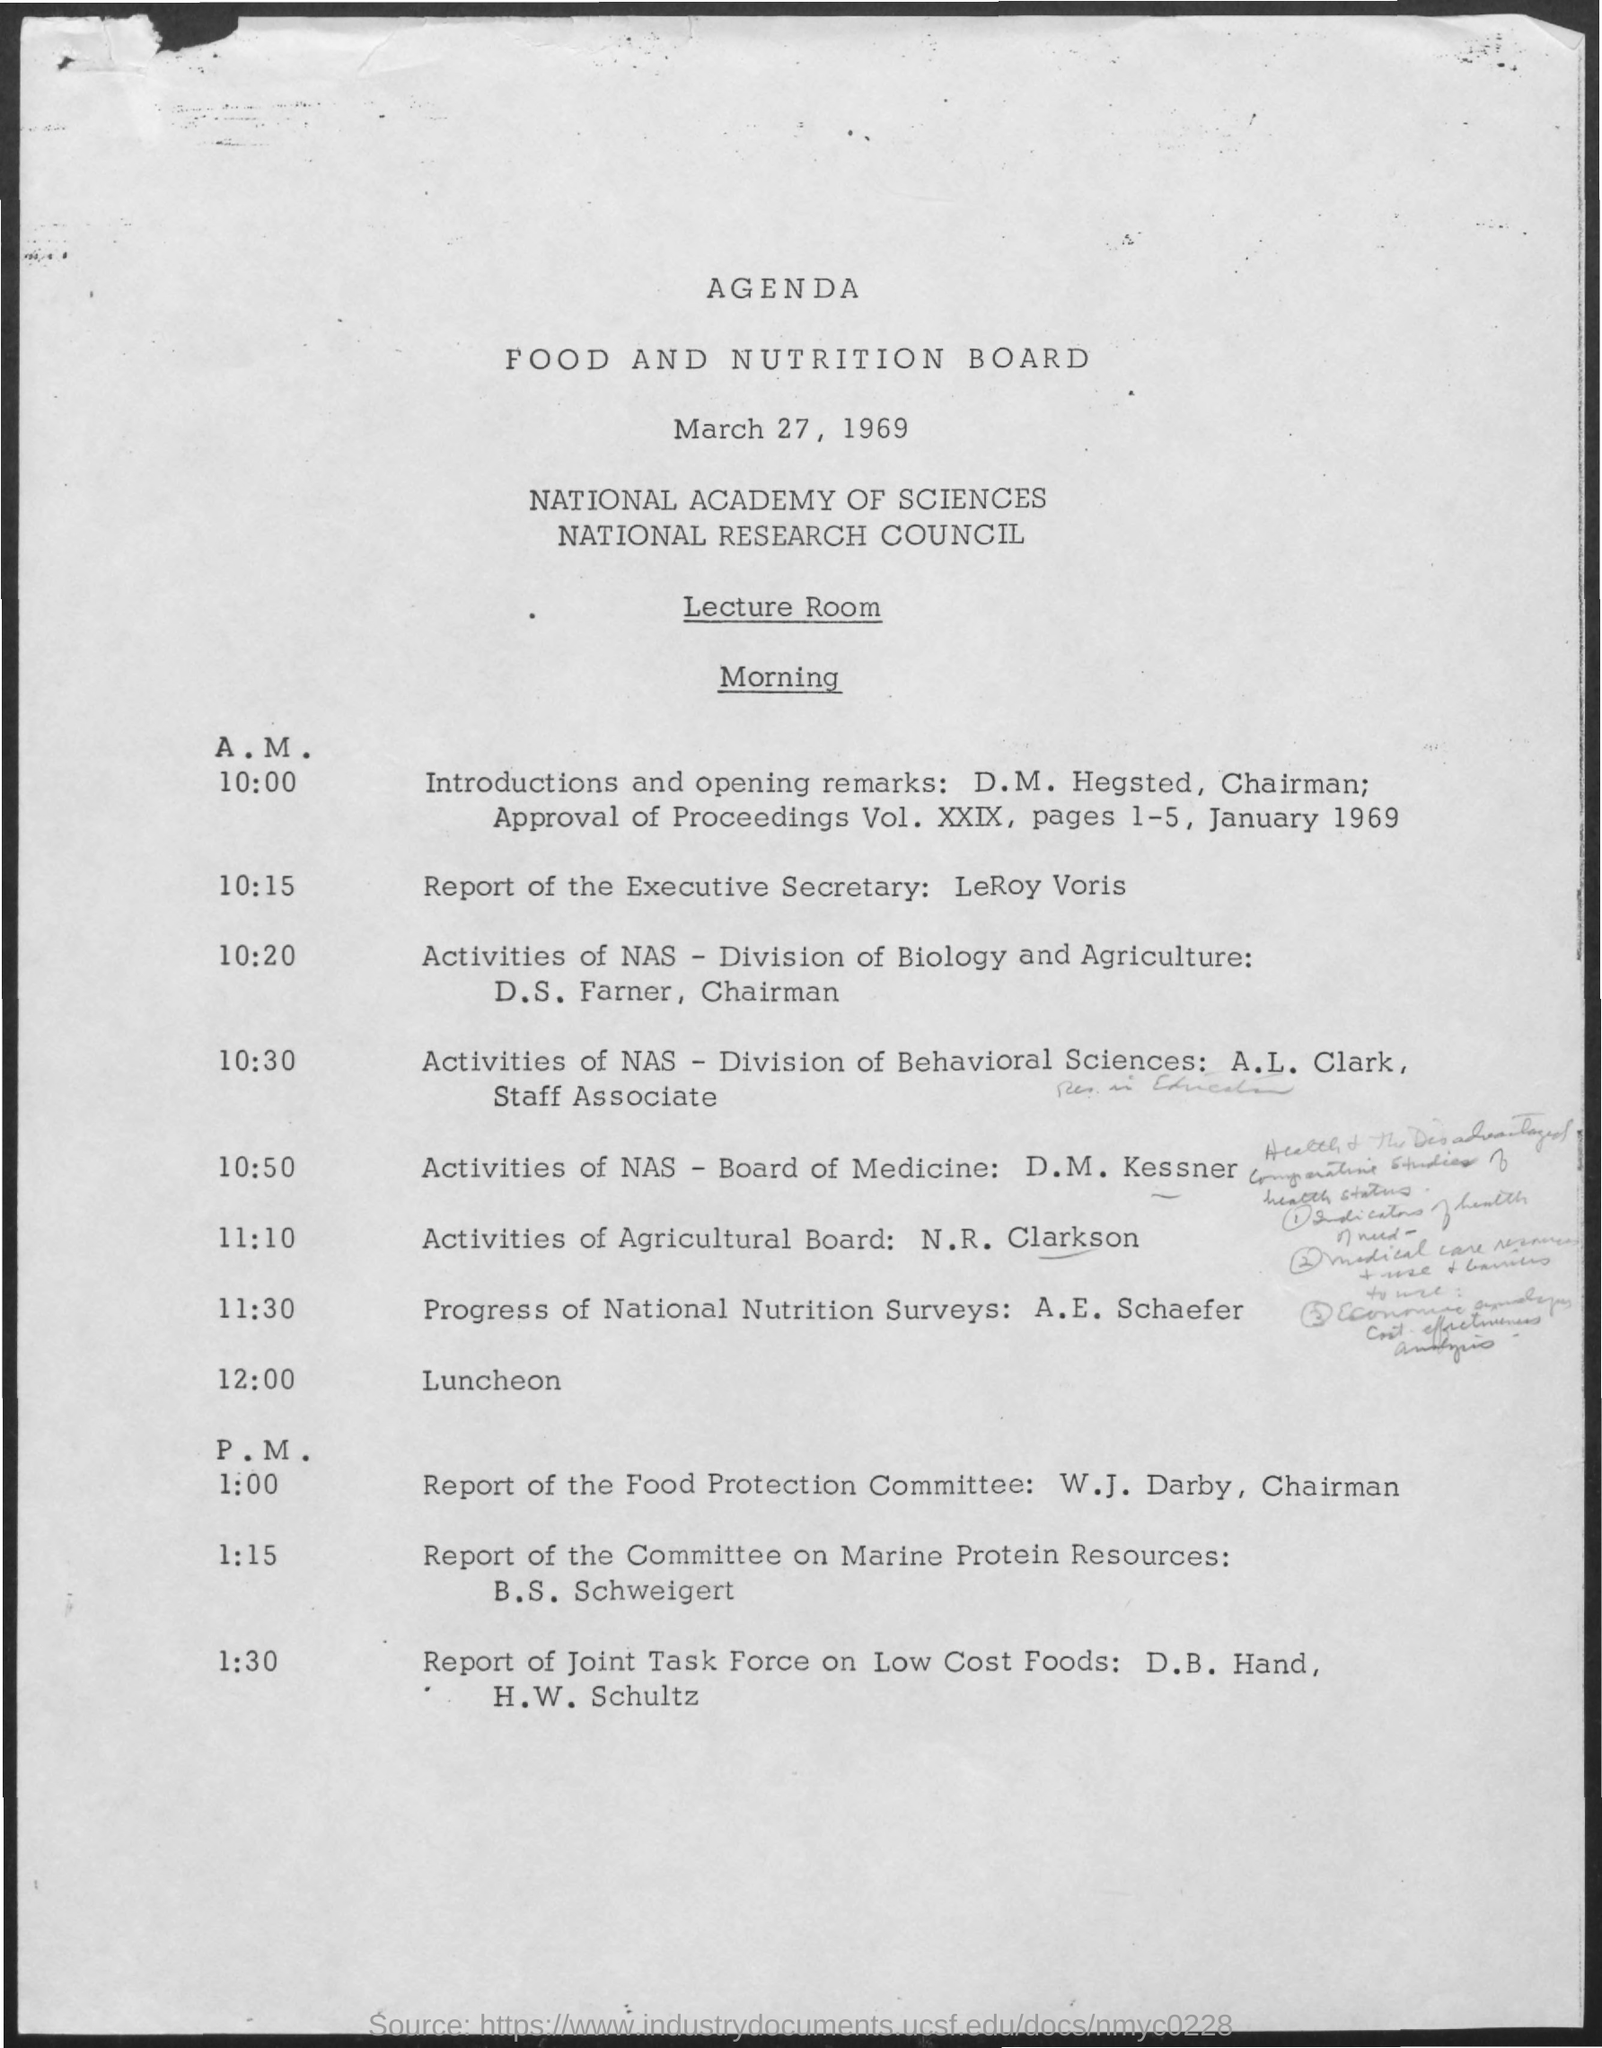Outline some significant characteristics in this image. The date mentioned in the document is March 27, 1969. 